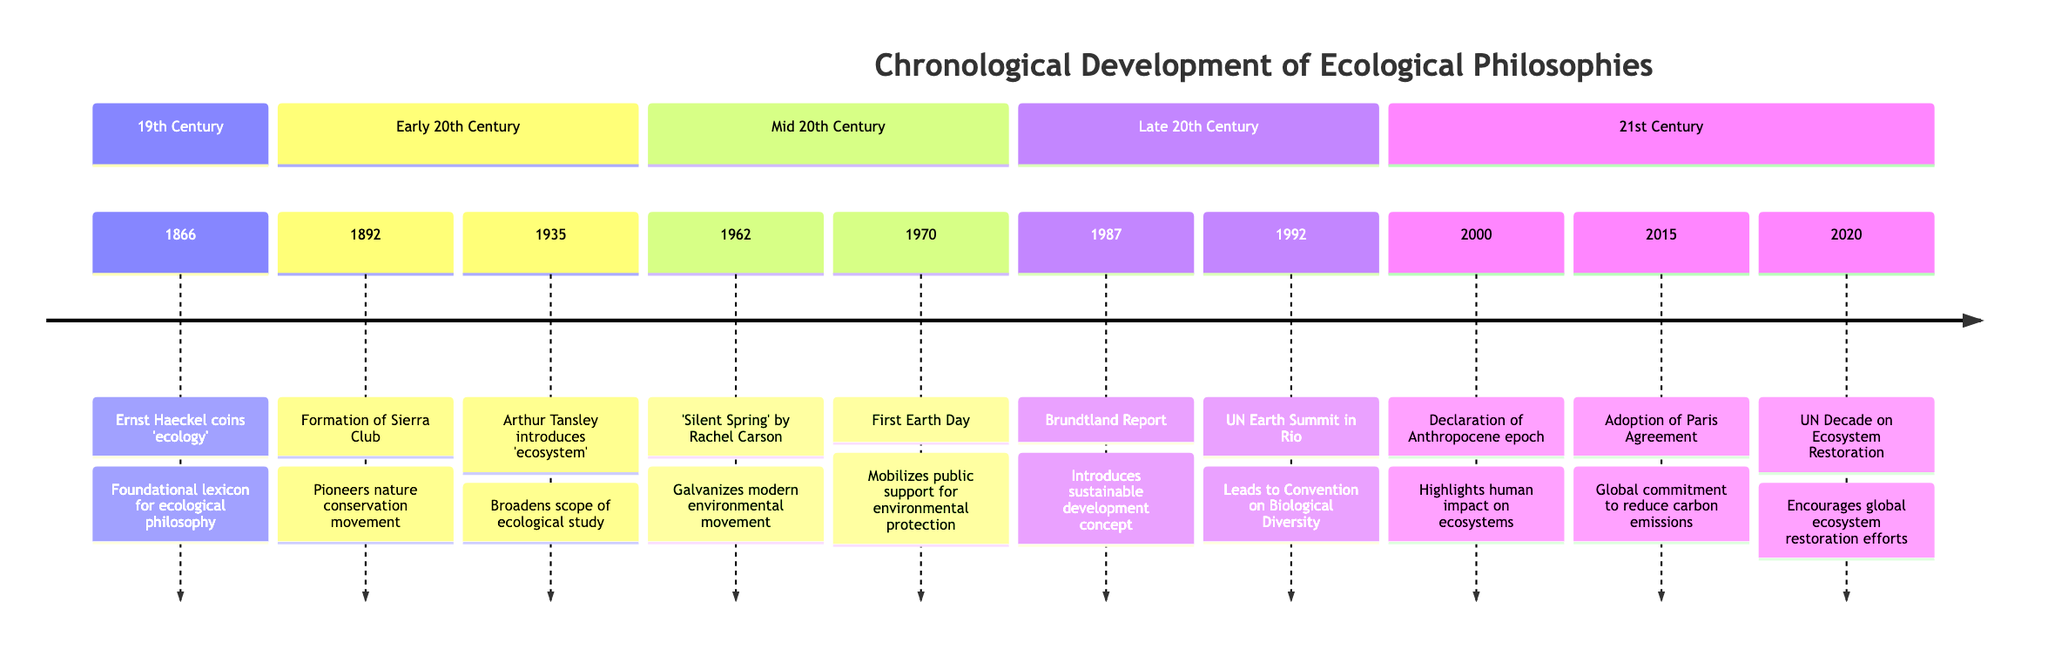What year did Ernst Haeckel coin the term 'ecology'? According to the timeline, Ernst Haeckel coined the term 'ecology' in the year 1866.
Answer: 1866 What event is associated with the year 1970? The timeline indicates that the event associated with the year 1970 is the First Earth Day.
Answer: First Earth Day How many key events occurred in the 21st Century section? By counting the events listed in the 21st Century section of the timeline, there are three key events: Declaration of the Anthropocene epoch, Adoption of the Paris Agreement, and UN Decade on Ecosystem Restoration.
Answer: 3 What impact did 'Silent Spring' by Rachel Carson have? The impact stated in the timeline is that it galvanized the modern environmental movement.
Answer: Galvanizes modern environmental movement Which event led to the establishment of the Convention on Biological Diversity? The timeline shows that the United Nations Earth Summit in Rio de Janeiro in 1992 led to the establishment of the Convention on Biological Diversity.
Answer: UN Earth Summit in Rio In what year was the Brundtland Report published? Referring to the timeline, the Brundtland Report was published in the year 1987.
Answer: 1987 What major global commitment was made in 2015? The timeline indicates that in 2015, the major global commitment made was the adoption of the Paris Agreement to limit global warming.
Answer: Adoption of the Paris Agreement How did the formation of the Sierra Club in 1892 influence conservation? The timeline states that the formation of the Sierra Club pioneered the nature conservation movement, influencing future policies and conservation strategies.
Answer: Pioneers nature conservation movement What was the main focus of the United Nations' Decade on Ecosystem Restoration in 2020? According to the timeline, the main focus of the United Nations' Decade on Ecosystem Restoration was to encourage global efforts to restore damaged ecosystems.
Answer: Encourages global ecosystem restoration efforts 